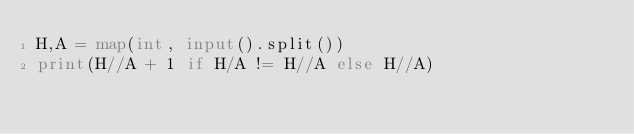<code> <loc_0><loc_0><loc_500><loc_500><_Python_>H,A = map(int, input().split())
print(H//A + 1 if H/A != H//A else H//A)</code> 